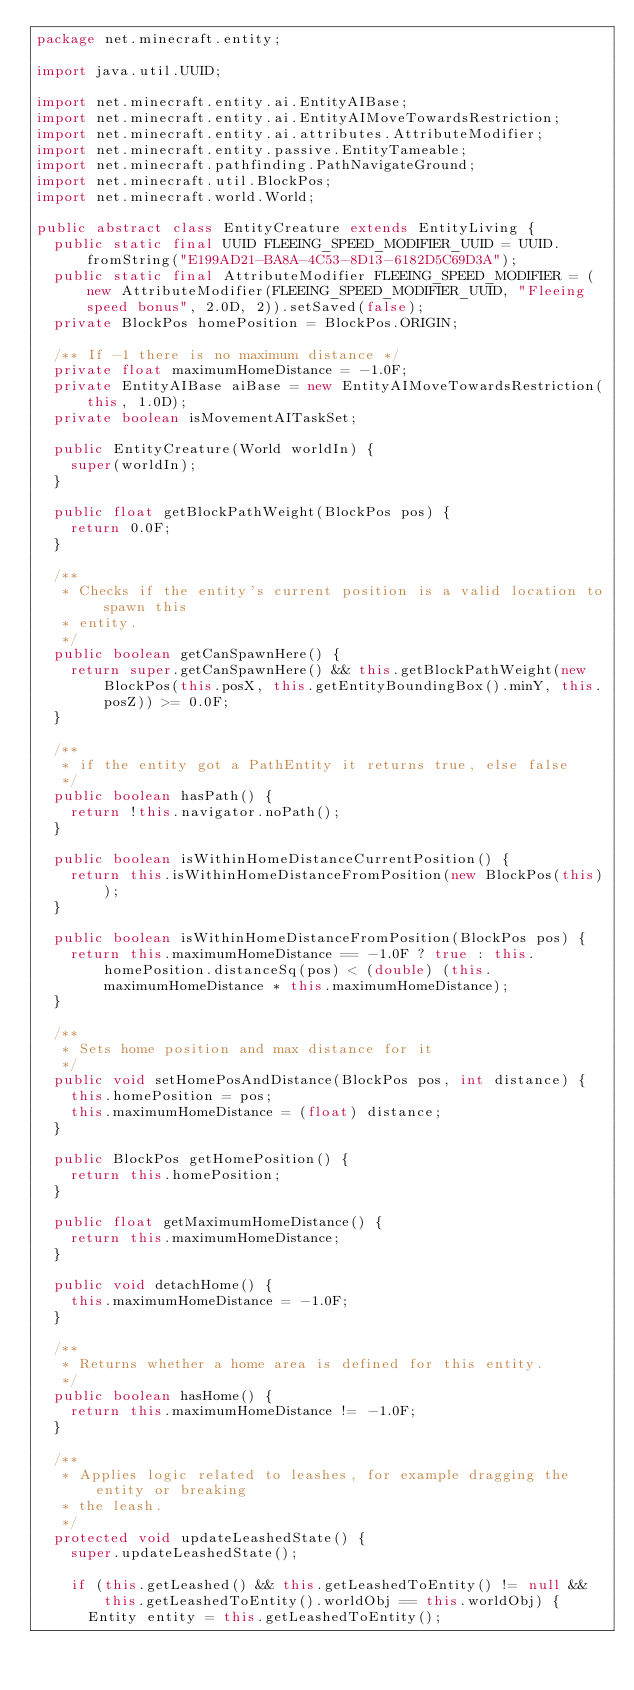<code> <loc_0><loc_0><loc_500><loc_500><_Java_>package net.minecraft.entity;

import java.util.UUID;

import net.minecraft.entity.ai.EntityAIBase;
import net.minecraft.entity.ai.EntityAIMoveTowardsRestriction;
import net.minecraft.entity.ai.attributes.AttributeModifier;
import net.minecraft.entity.passive.EntityTameable;
import net.minecraft.pathfinding.PathNavigateGround;
import net.minecraft.util.BlockPos;
import net.minecraft.world.World;

public abstract class EntityCreature extends EntityLiving {
	public static final UUID FLEEING_SPEED_MODIFIER_UUID = UUID.fromString("E199AD21-BA8A-4C53-8D13-6182D5C69D3A");
	public static final AttributeModifier FLEEING_SPEED_MODIFIER = (new AttributeModifier(FLEEING_SPEED_MODIFIER_UUID, "Fleeing speed bonus", 2.0D, 2)).setSaved(false);
	private BlockPos homePosition = BlockPos.ORIGIN;

	/** If -1 there is no maximum distance */
	private float maximumHomeDistance = -1.0F;
	private EntityAIBase aiBase = new EntityAIMoveTowardsRestriction(this, 1.0D);
	private boolean isMovementAITaskSet;

	public EntityCreature(World worldIn) {
		super(worldIn);
	}

	public float getBlockPathWeight(BlockPos pos) {
		return 0.0F;
	}

	/**
	 * Checks if the entity's current position is a valid location to spawn this
	 * entity.
	 */
	public boolean getCanSpawnHere() {
		return super.getCanSpawnHere() && this.getBlockPathWeight(new BlockPos(this.posX, this.getEntityBoundingBox().minY, this.posZ)) >= 0.0F;
	}

	/**
	 * if the entity got a PathEntity it returns true, else false
	 */
	public boolean hasPath() {
		return !this.navigator.noPath();
	}

	public boolean isWithinHomeDistanceCurrentPosition() {
		return this.isWithinHomeDistanceFromPosition(new BlockPos(this));
	}

	public boolean isWithinHomeDistanceFromPosition(BlockPos pos) {
		return this.maximumHomeDistance == -1.0F ? true : this.homePosition.distanceSq(pos) < (double) (this.maximumHomeDistance * this.maximumHomeDistance);
	}

	/**
	 * Sets home position and max distance for it
	 */
	public void setHomePosAndDistance(BlockPos pos, int distance) {
		this.homePosition = pos;
		this.maximumHomeDistance = (float) distance;
	}

	public BlockPos getHomePosition() {
		return this.homePosition;
	}

	public float getMaximumHomeDistance() {
		return this.maximumHomeDistance;
	}

	public void detachHome() {
		this.maximumHomeDistance = -1.0F;
	}

	/**
	 * Returns whether a home area is defined for this entity.
	 */
	public boolean hasHome() {
		return this.maximumHomeDistance != -1.0F;
	}

	/**
	 * Applies logic related to leashes, for example dragging the entity or breaking
	 * the leash.
	 */
	protected void updateLeashedState() {
		super.updateLeashedState();

		if (this.getLeashed() && this.getLeashedToEntity() != null && this.getLeashedToEntity().worldObj == this.worldObj) {
			Entity entity = this.getLeashedToEntity();</code> 